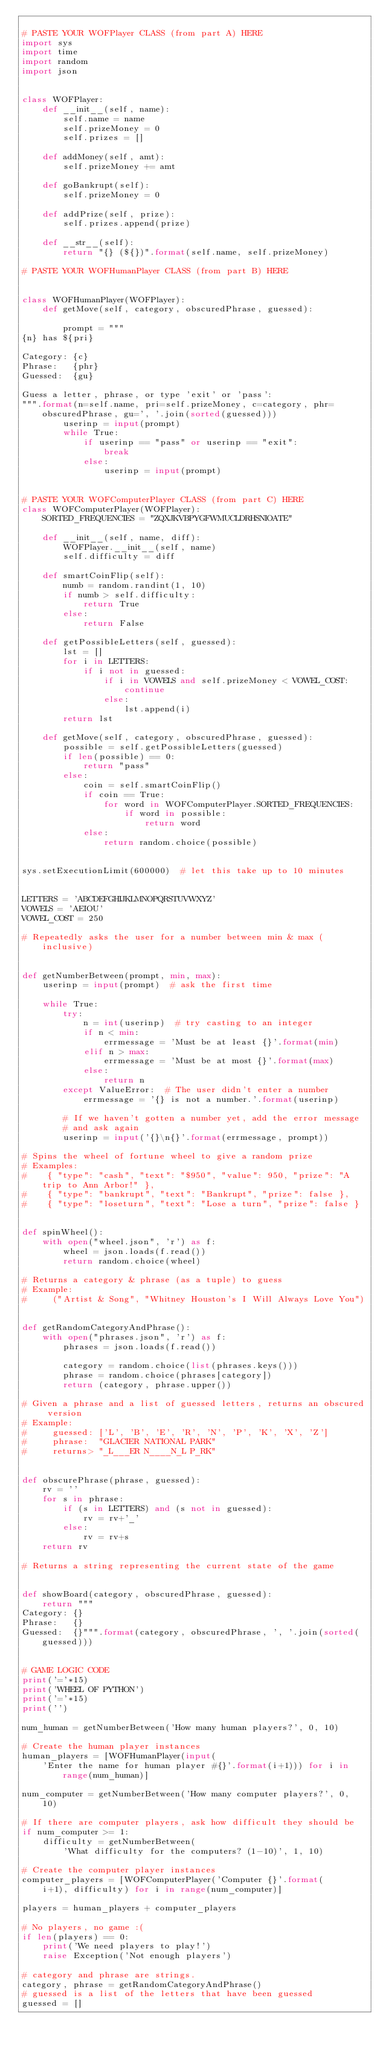Convert code to text. <code><loc_0><loc_0><loc_500><loc_500><_Python_>
# PASTE YOUR WOFPlayer CLASS (from part A) HERE
import sys
import time
import random
import json


class WOFPlayer:
    def __init__(self, name):
        self.name = name
        self.prizeMoney = 0
        self.prizes = []

    def addMoney(self, amt):
        self.prizeMoney += amt

    def goBankrupt(self):
        self.prizeMoney = 0

    def addPrize(self, prize):
        self.prizes.append(prize)

    def __str__(self):
        return "{} (${})".format(self.name, self.prizeMoney)

# PASTE YOUR WOFHumanPlayer CLASS (from part B) HERE


class WOFHumanPlayer(WOFPlayer):
    def getMove(self, category, obscuredPhrase, guessed):

        prompt = """
{n} has ${pri}

Category: {c}
Phrase:   {phr}
Guessed:  {gu} 

Guess a letter, phrase, or type 'exit' or 'pass':
""".format(n=self.name, pri=self.prizeMoney, c=category, phr=obscuredPhrase, gu=', '.join(sorted(guessed)))
        userinp = input(prompt)
        while True:
            if userinp == "pass" or userinp == "exit":
                break
            else:
                userinp = input(prompt)


# PASTE YOUR WOFComputerPlayer CLASS (from part C) HERE
class WOFComputerPlayer(WOFPlayer):
    SORTED_FREQUENCIES = "ZQXJKVBPYGFWMUCLDRHSNIOATE"

    def __init__(self, name, diff):
        WOFPlayer.__init__(self, name)
        self.difficulty = diff

    def smartCoinFlip(self):
        numb = random.randint(1, 10)
        if numb > self.difficulty:
            return True
        else:
            return False

    def getPossibleLetters(self, guessed):
        lst = []
        for i in LETTERS:
            if i not in guessed:
                if i in VOWELS and self.prizeMoney < VOWEL_COST:
                    continue
                else:
                    lst.append(i)
        return lst

    def getMove(self, category, obscuredPhrase, guessed):
        possible = self.getPossibleLetters(guessed)
        if len(possible) == 0:
            return "pass"
        else:
            coin = self.smartCoinFlip()
            if coin == True:
                for word in WOFComputerPlayer.SORTED_FREQUENCIES:
                    if word in possible:
                        return word
            else:
                return random.choice(possible)


sys.setExecutionLimit(600000)  # let this take up to 10 minutes


LETTERS = 'ABCDEFGHIJKLMNOPQRSTUVWXYZ'
VOWELS = 'AEIOU'
VOWEL_COST = 250

# Repeatedly asks the user for a number between min & max (inclusive)


def getNumberBetween(prompt, min, max):
    userinp = input(prompt)  # ask the first time

    while True:
        try:
            n = int(userinp)  # try casting to an integer
            if n < min:
                errmessage = 'Must be at least {}'.format(min)
            elif n > max:
                errmessage = 'Must be at most {}'.format(max)
            else:
                return n
        except ValueError:  # The user didn't enter a number
            errmessage = '{} is not a number.'.format(userinp)

        # If we haven't gotten a number yet, add the error message
        # and ask again
        userinp = input('{}\n{}'.format(errmessage, prompt))

# Spins the wheel of fortune wheel to give a random prize
# Examples:
#    { "type": "cash", "text": "$950", "value": 950, "prize": "A trip to Ann Arbor!" },
#    { "type": "bankrupt", "text": "Bankrupt", "prize": false },
#    { "type": "loseturn", "text": "Lose a turn", "prize": false }


def spinWheel():
    with open("wheel.json", 'r') as f:
        wheel = json.loads(f.read())
        return random.choice(wheel)

# Returns a category & phrase (as a tuple) to guess
# Example:
#     ("Artist & Song", "Whitney Houston's I Will Always Love You")


def getRandomCategoryAndPhrase():
    with open("phrases.json", 'r') as f:
        phrases = json.loads(f.read())

        category = random.choice(list(phrases.keys()))
        phrase = random.choice(phrases[category])
        return (category, phrase.upper())

# Given a phrase and a list of guessed letters, returns an obscured version
# Example:
#     guessed: ['L', 'B', 'E', 'R', 'N', 'P', 'K', 'X', 'Z']
#     phrase:  "GLACIER NATIONAL PARK"
#     returns> "_L___ER N____N_L P_RK"


def obscurePhrase(phrase, guessed):
    rv = ''
    for s in phrase:
        if (s in LETTERS) and (s not in guessed):
            rv = rv+'_'
        else:
            rv = rv+s
    return rv

# Returns a string representing the current state of the game


def showBoard(category, obscuredPhrase, guessed):
    return """
Category: {}
Phrase:   {}
Guessed:  {}""".format(category, obscuredPhrase, ', '.join(sorted(guessed)))


# GAME LOGIC CODE
print('='*15)
print('WHEEL OF PYTHON')
print('='*15)
print('')

num_human = getNumberBetween('How many human players?', 0, 10)

# Create the human player instances
human_players = [WOFHumanPlayer(input(
    'Enter the name for human player #{}'.format(i+1))) for i in range(num_human)]

num_computer = getNumberBetween('How many computer players?', 0, 10)

# If there are computer players, ask how difficult they should be
if num_computer >= 1:
    difficulty = getNumberBetween(
        'What difficulty for the computers? (1-10)', 1, 10)

# Create the computer player instances
computer_players = [WOFComputerPlayer('Computer {}'.format(
    i+1), difficulty) for i in range(num_computer)]

players = human_players + computer_players

# No players, no game :(
if len(players) == 0:
    print('We need players to play!')
    raise Exception('Not enough players')

# category and phrase are strings.
category, phrase = getRandomCategoryAndPhrase()
# guessed is a list of the letters that have been guessed
guessed = []
</code> 